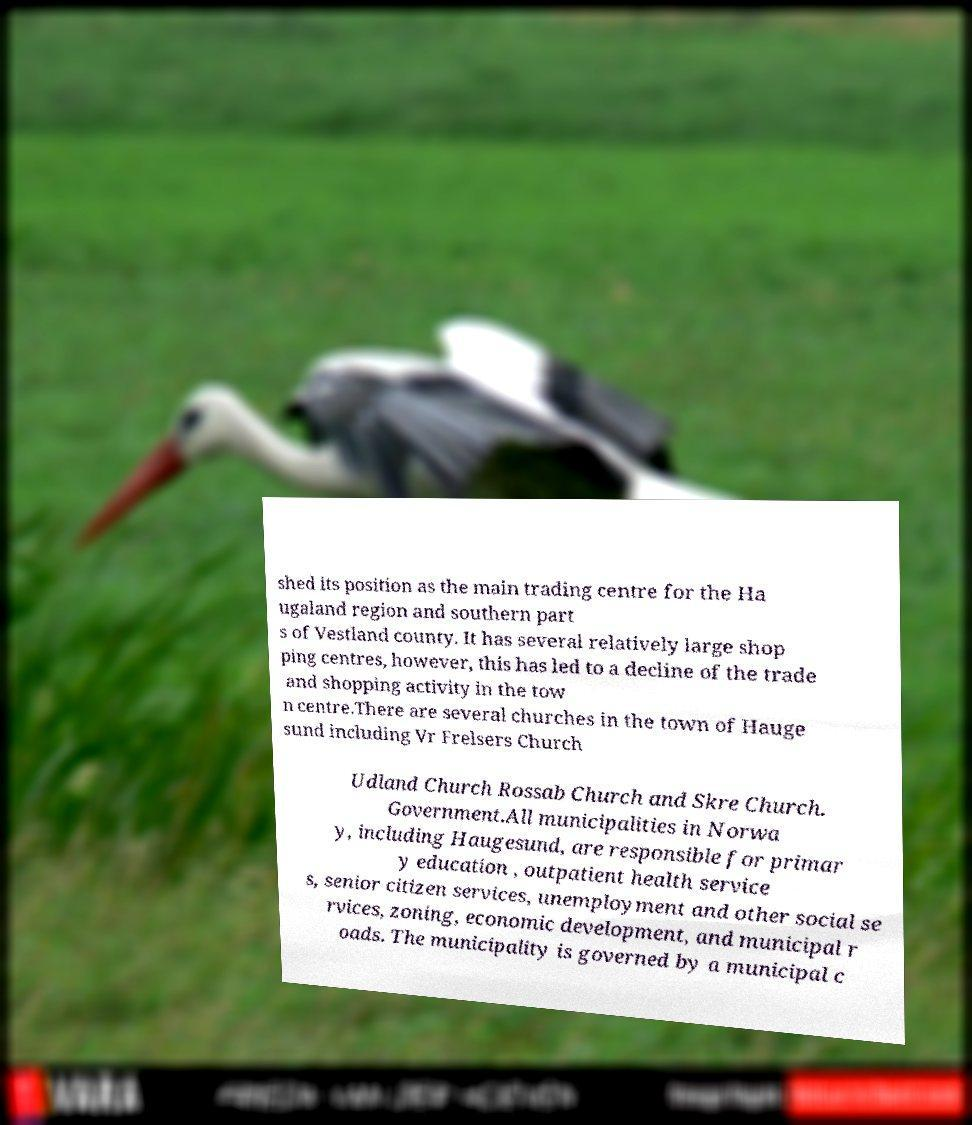For documentation purposes, I need the text within this image transcribed. Could you provide that? shed its position as the main trading centre for the Ha ugaland region and southern part s of Vestland county. It has several relatively large shop ping centres, however, this has led to a decline of the trade and shopping activity in the tow n centre.There are several churches in the town of Hauge sund including Vr Frelsers Church Udland Church Rossab Church and Skre Church. Government.All municipalities in Norwa y, including Haugesund, are responsible for primar y education , outpatient health service s, senior citizen services, unemployment and other social se rvices, zoning, economic development, and municipal r oads. The municipality is governed by a municipal c 